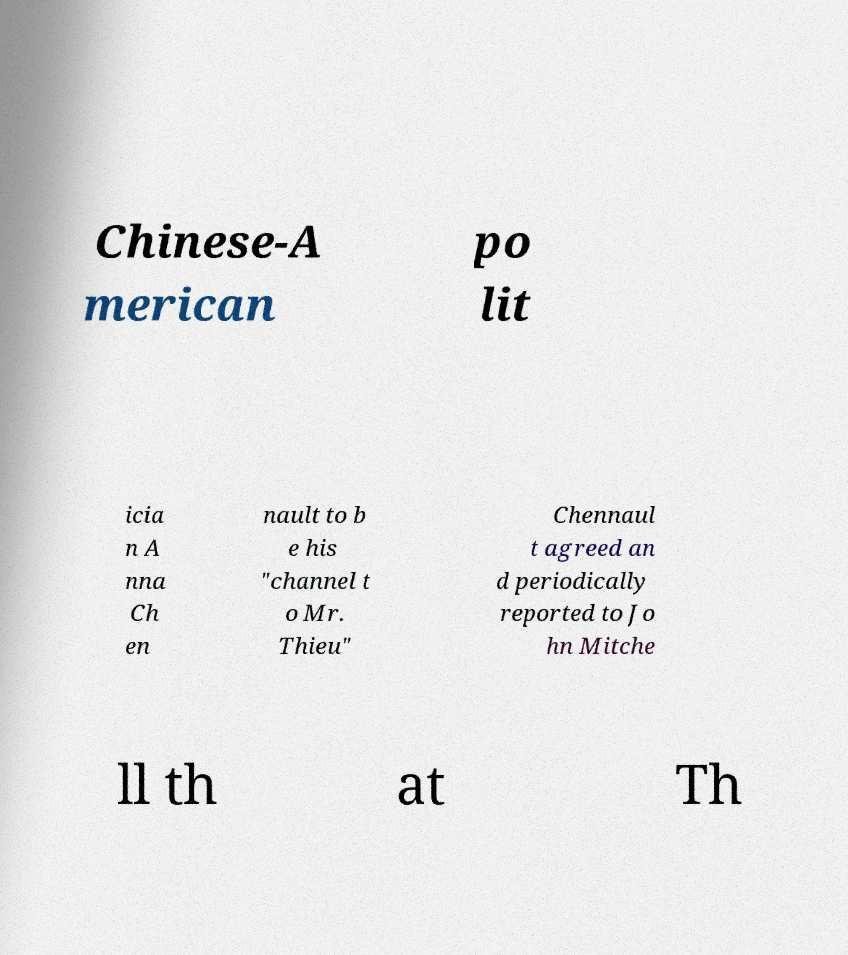Could you assist in decoding the text presented in this image and type it out clearly? Chinese-A merican po lit icia n A nna Ch en nault to b e his "channel t o Mr. Thieu" Chennaul t agreed an d periodically reported to Jo hn Mitche ll th at Th 